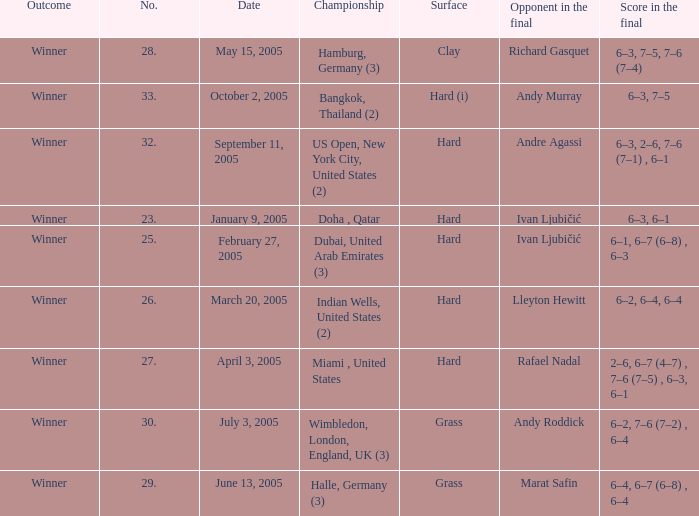Andy Roddick is the opponent in the final on what surface? Grass. 